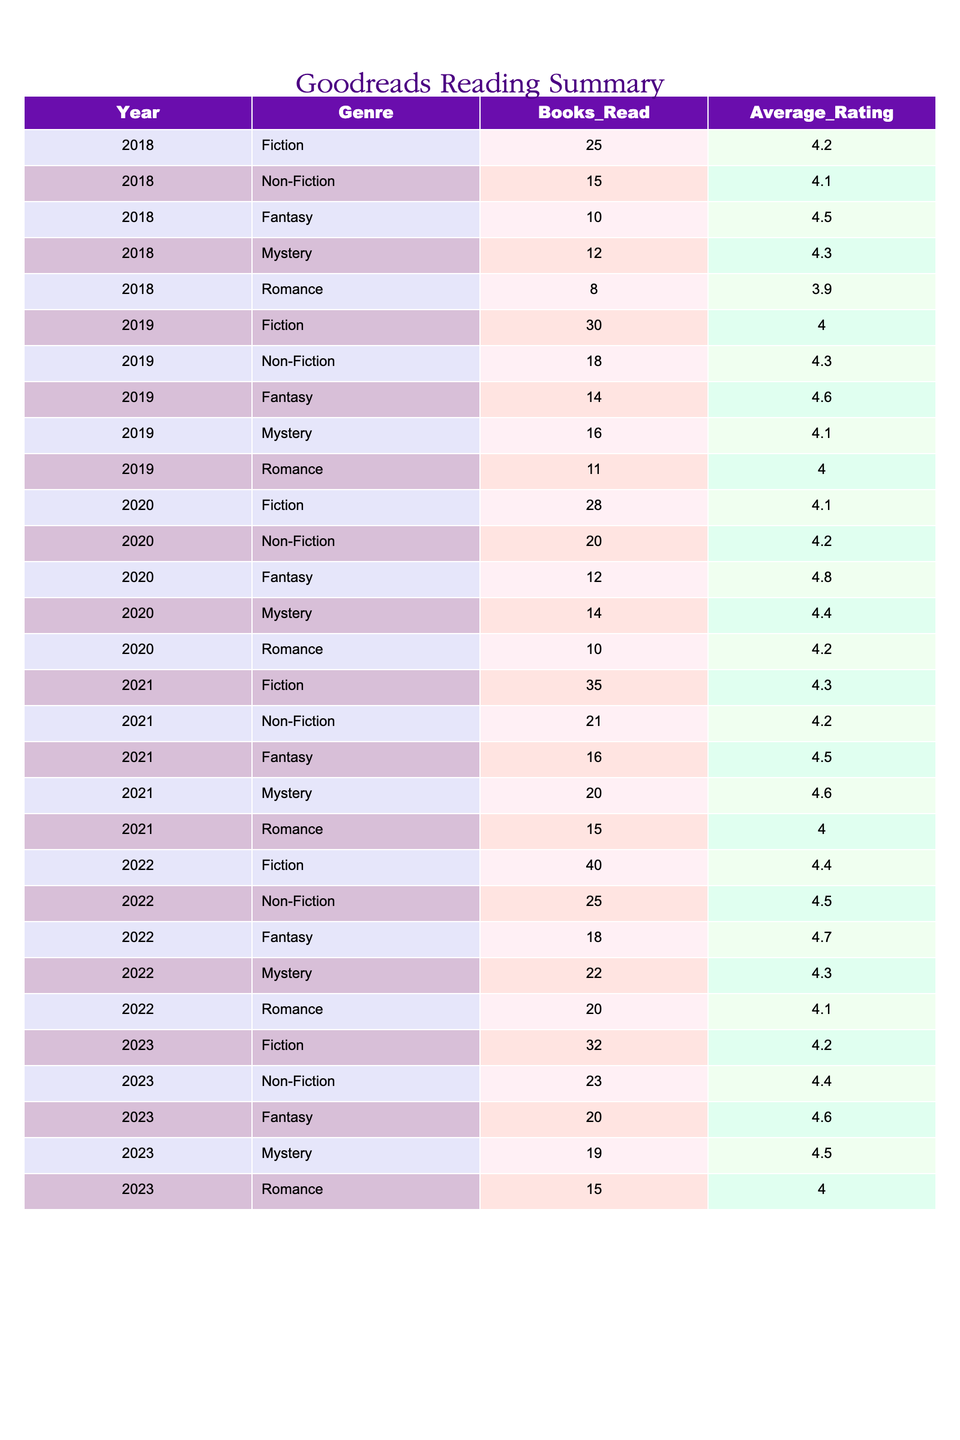What genre had the highest average rating in 2021? In 2021, the genres and their average ratings were: Fiction (4.3), Non-Fiction (4.2), Fantasy (4.5), Mystery (4.6), Romance (4.0). The highest average rating is 4.6, which belongs to the Mystery genre.
Answer: Mystery How many Fiction books were read in 2022? Referring to the 2022 data, the number of Fiction books read is 40.
Answer: 40 What was the total number of Fantasy books read from 2018 to 2020? The number of Fantasy books read each year is as follows: 2018 (10), 2019 (14), and 2020 (12). Adding these numbers gives us 10 + 14 + 12 = 36.
Answer: 36 Did more Non-Fiction or Fiction books get read in 2019? In 2019, the number of books read were: Non-Fiction (18) and Fiction (30). Since 30 > 18, more Fiction books were read in 2019.
Answer: Yes Which genre had the most significant increase in the number of books read from 2020 to 2021? The number of books read in 2020 were: Fiction (28), Non-Fiction (20), Fantasy (12), Mystery (14), Romance (10) and in 2021: Fiction (35), Non-Fiction (21), Fantasy (16), Mystery (20), Romance (15). The increases are Fiction (+7), Non-Fiction (+1), Fantasy (+4), Mystery (+6), Romance (+5). Fiction saw the largest increase of 7.
Answer: Fiction In which year did Romance have the highest average rating? The average ratings for the Romance genre are: 2018 (3.9), 2019 (4.0), 2020 (4.2), 2021 (4.0), 2022 (4.1), and 2023 (4.0). The highest average is 4.2, which occurred in 2020.
Answer: 2020 What is the total number of books read across all genres in 2023? The number of books read in 2023 for each genre are: Fiction (32), Non-Fiction (23), Fantasy (20), Mystery (19), Romance (15). Adding these gives: 32 + 23 + 20 + 19 + 15 = 109.
Answer: 109 What was the average rating of Mystery books across all years? The average Mystery ratings over the years are: 2018 (4.3), 2019 (4.1), 2020 (4.4), 2021 (4.6), 2022 (4.3), and 2023 (4.5). The total sum of these ratings is 4.3 + 4.1 + 4.4 + 4.6 + 4.3 + 4.5 = 26.2, and there are 6 data points. Thus, the average is 26.2 / 6 ≈ 4.367
Answer: 4.367 